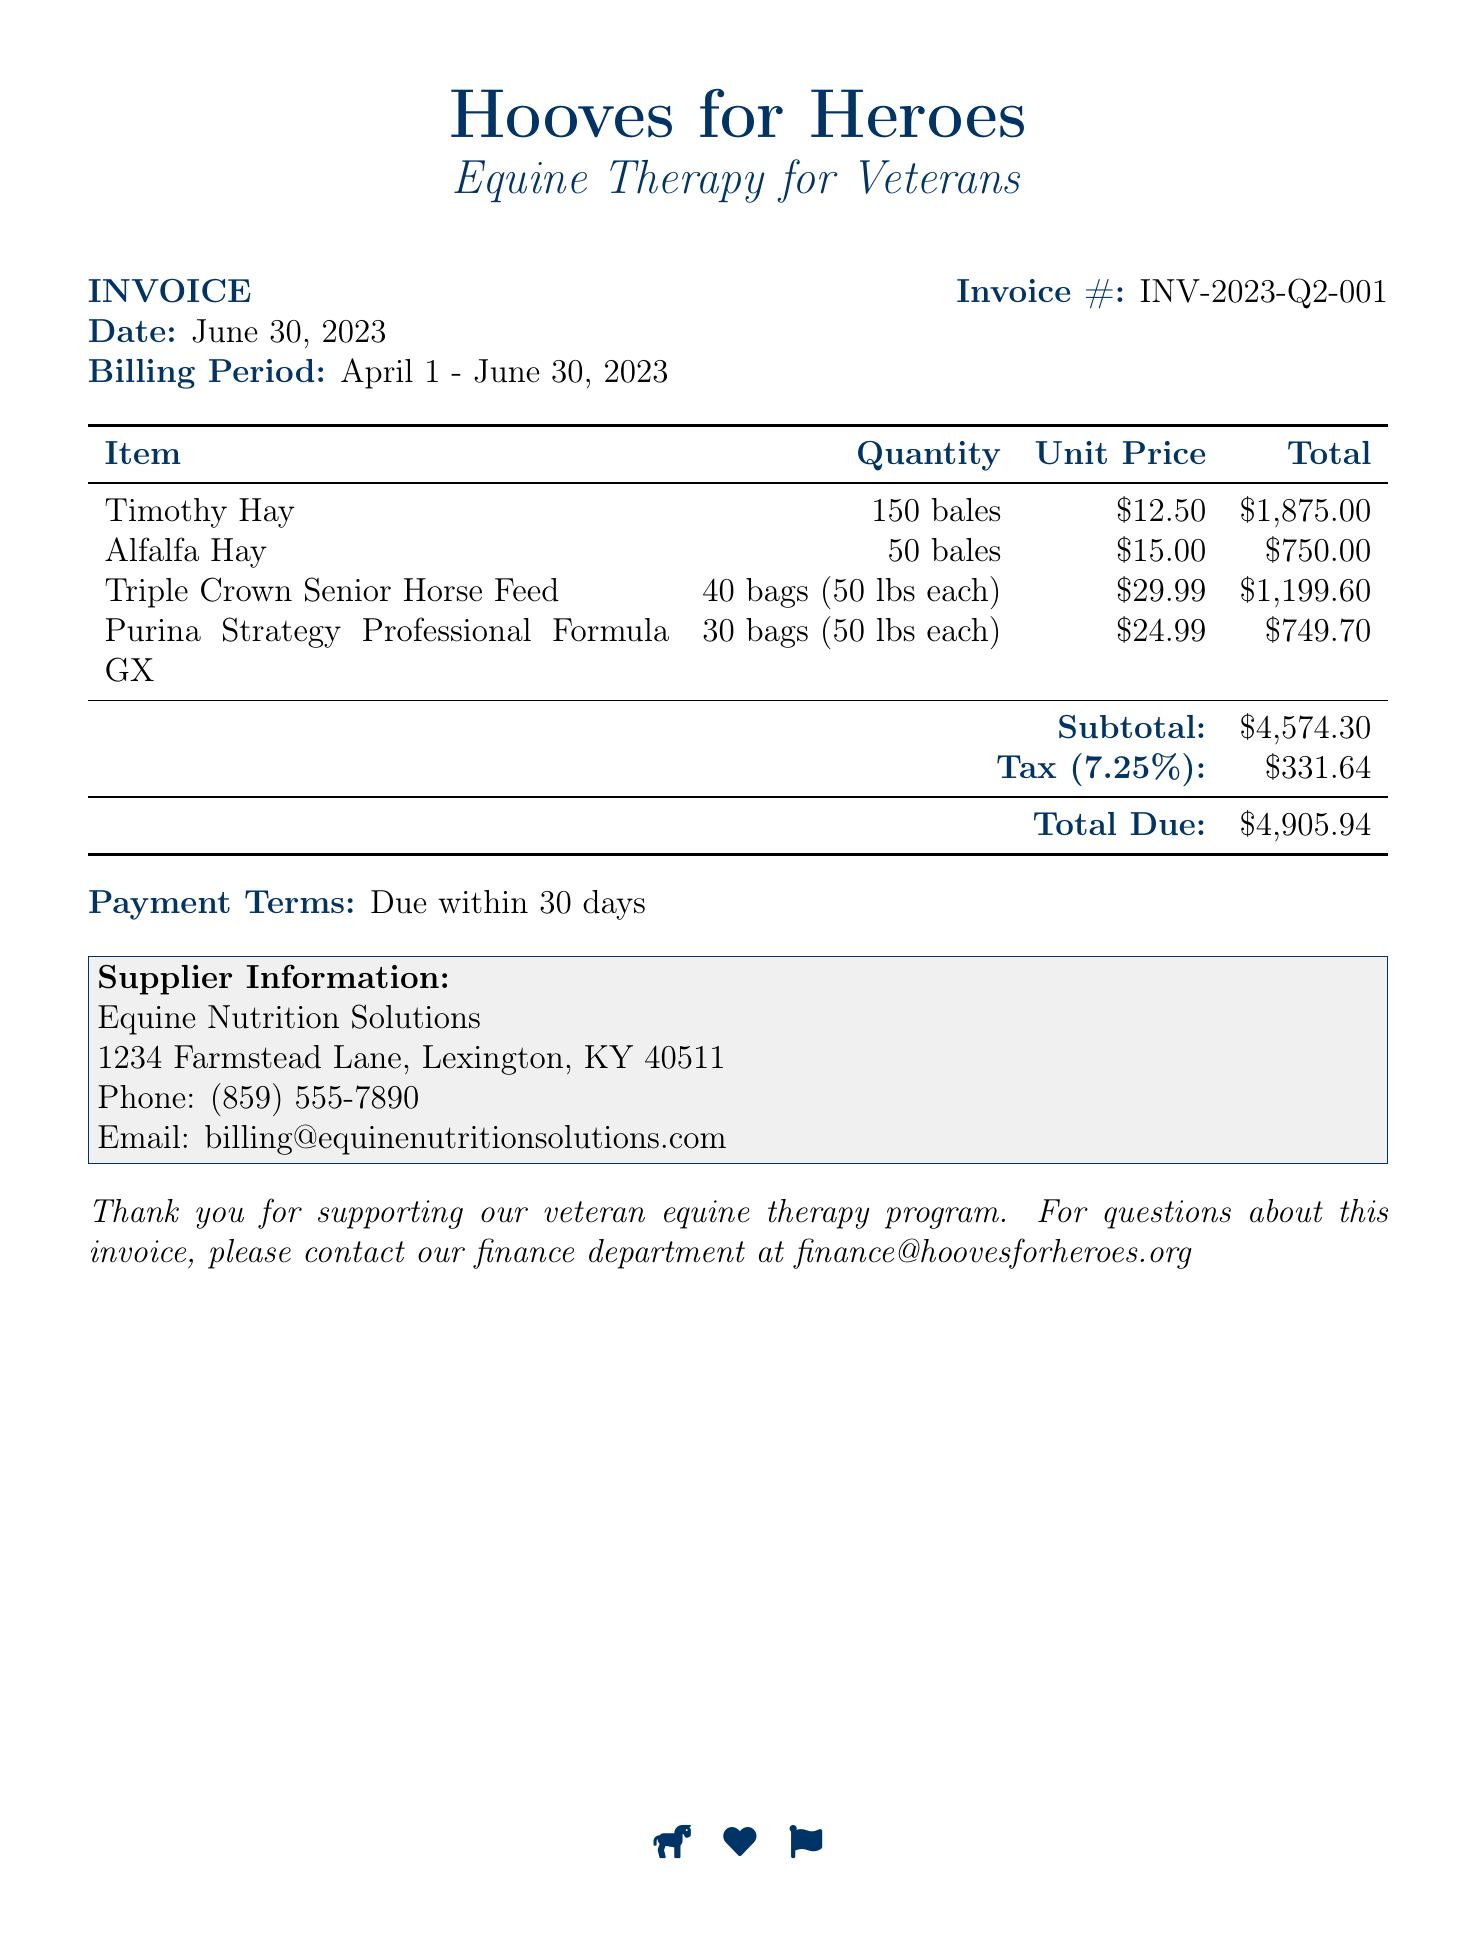What is the invoice number? The invoice number is found in the document header, which designates it uniquely.
Answer: INV-2023-Q2-001 What is the date of the invoice? The date of the invoice is stated clearly in the document.
Answer: June 30, 2023 What is the total amount due? The total due amount is calculated at the end of the invoice, summing up the subtotal and tax.
Answer: $4,905.94 How many bales of Timothy Hay were ordered? The document specifies the quantity of Timothy Hay under the item list.
Answer: 150 bales What is the tax rate applied? The tax rate is presented in the document, which indicates the percentage for calculation.
Answer: 7.25% What is the supplier's phone number? The supplier's contact information includes a phone number listed in the document.
Answer: (859) 555-7890 How many bags of Purina Strategy Professional Formula GX were purchased? The quantity for Purina Strategy Professional Formula GX is outlined in the item list.
Answer: 30 bags (50 lbs each) What is the unit price of Alfalfa Hay? The unit price for Alfalfa Hay is mentioned in the table of items.
Answer: $15.00 What is the subtotal before tax? The subtotal is clearly indicated in the amount section of the document before the tax is added.
Answer: $4,574.30 